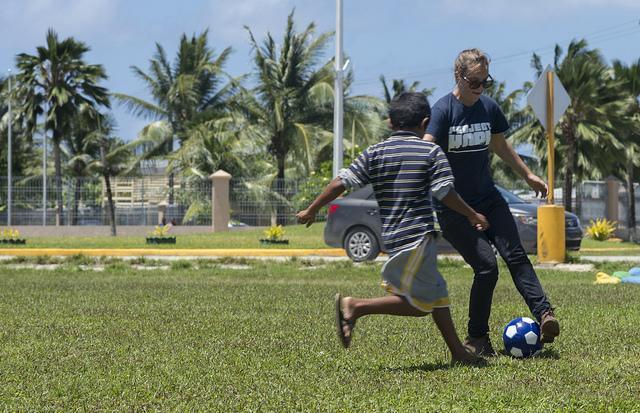How many people are in the grass?
Give a very brief answer. 2. How many people are visible?
Give a very brief answer. 2. How many elephants are lying down?
Give a very brief answer. 0. 